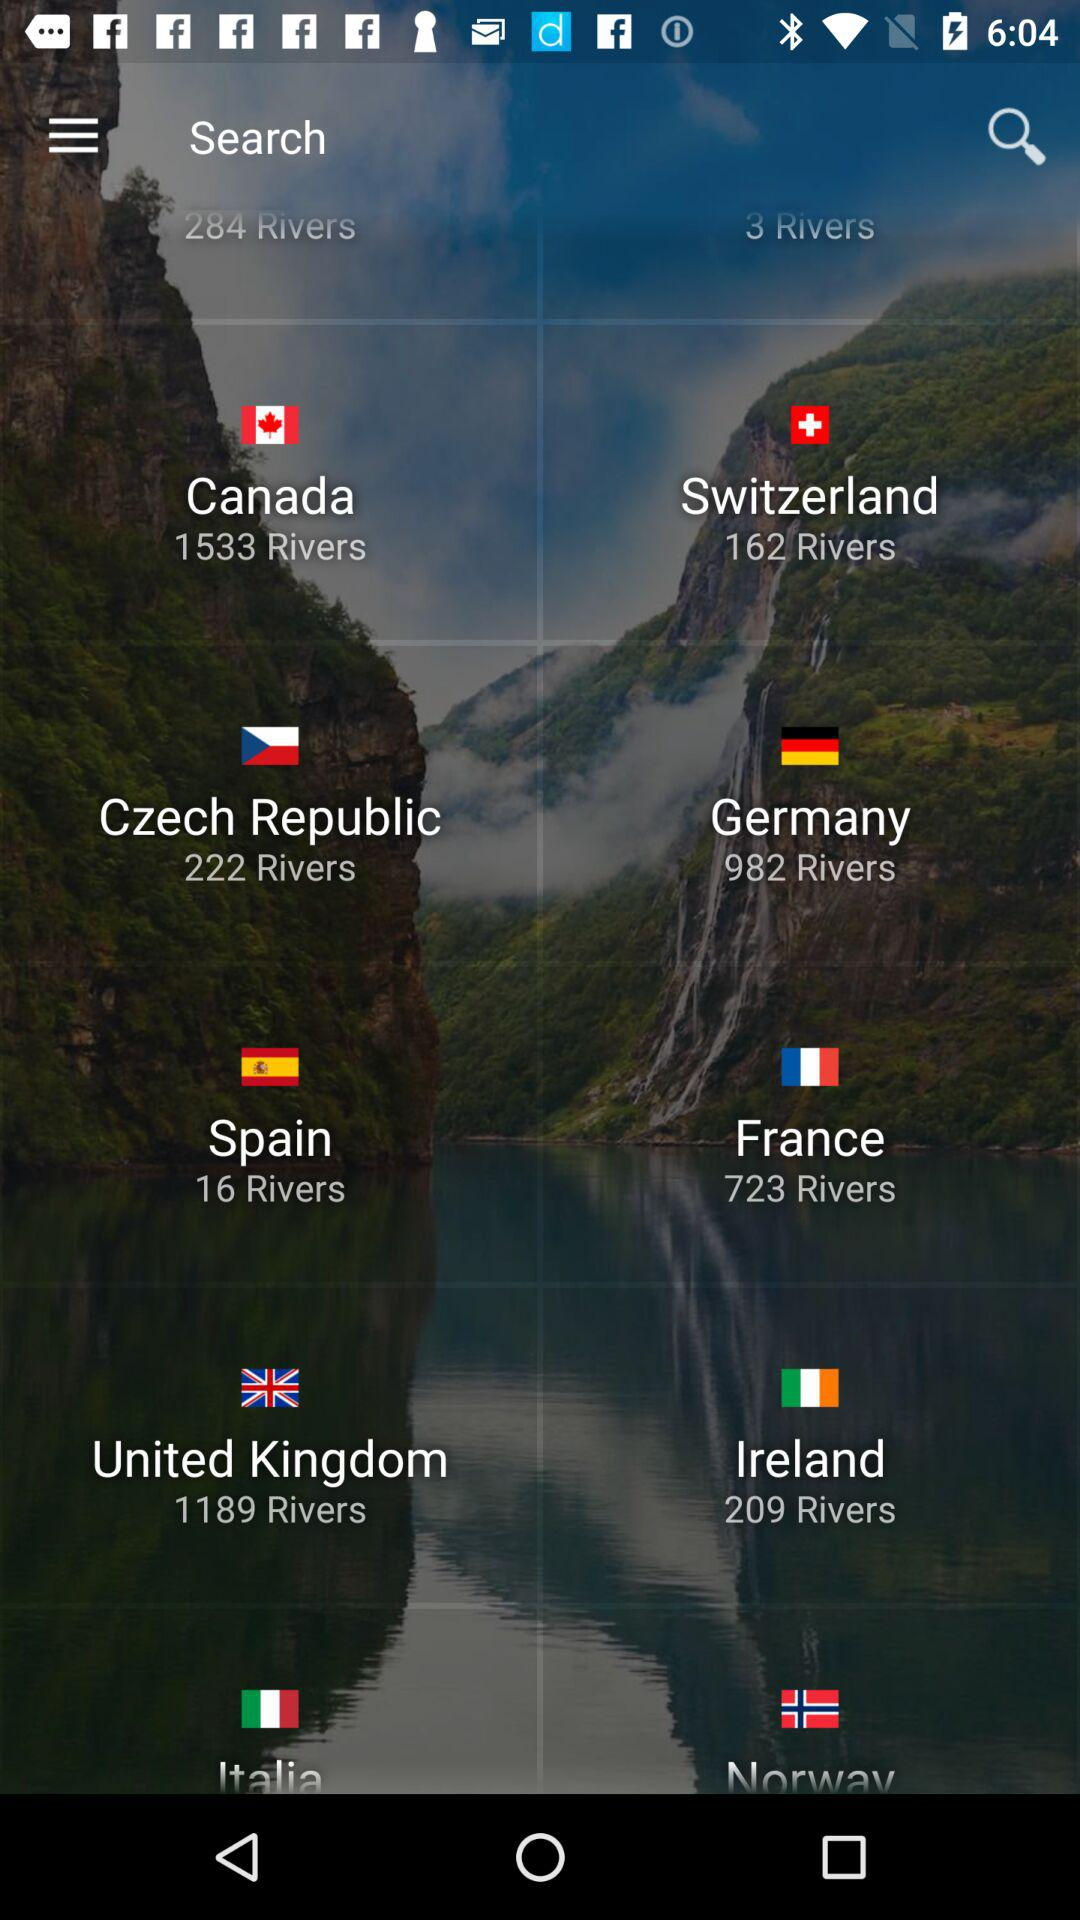Which country has 1189 rivers? The country is the United Kingdom. 